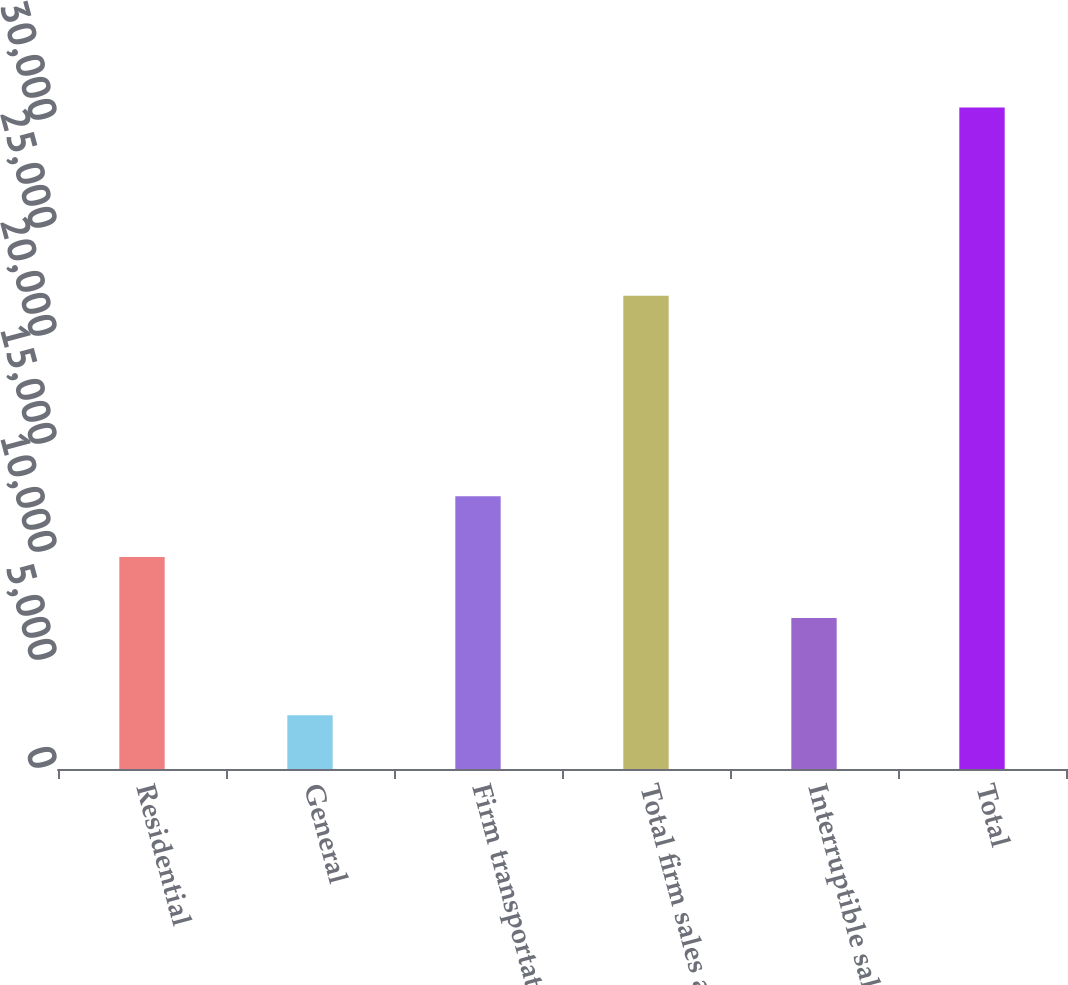<chart> <loc_0><loc_0><loc_500><loc_500><bar_chart><fcel>Residential<fcel>General<fcel>Firm transportation<fcel>Total firm sales and<fcel>Interruptible sales<fcel>Total<nl><fcel>9810.1<fcel>2487<fcel>12624.2<fcel>21905<fcel>6996<fcel>30628<nl></chart> 